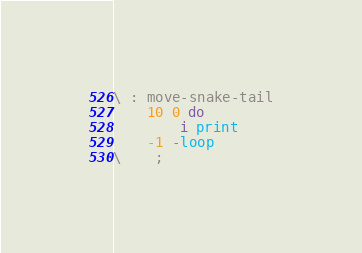<code> <loc_0><loc_0><loc_500><loc_500><_Forth_>\ : move-snake-tail
    10 0 do
        i print
    -1 -loop
\    ;
</code> 